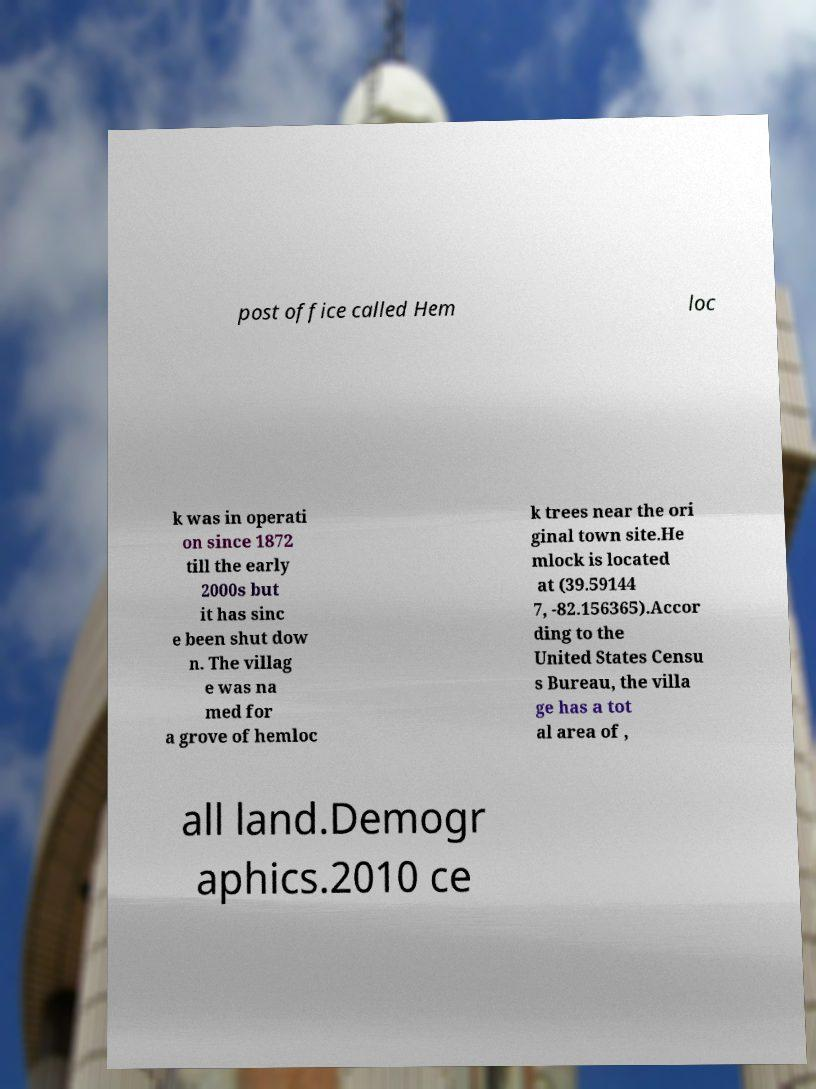Could you assist in decoding the text presented in this image and type it out clearly? post office called Hem loc k was in operati on since 1872 till the early 2000s but it has sinc e been shut dow n. The villag e was na med for a grove of hemloc k trees near the ori ginal town site.He mlock is located at (39.59144 7, -82.156365).Accor ding to the United States Censu s Bureau, the villa ge has a tot al area of , all land.Demogr aphics.2010 ce 